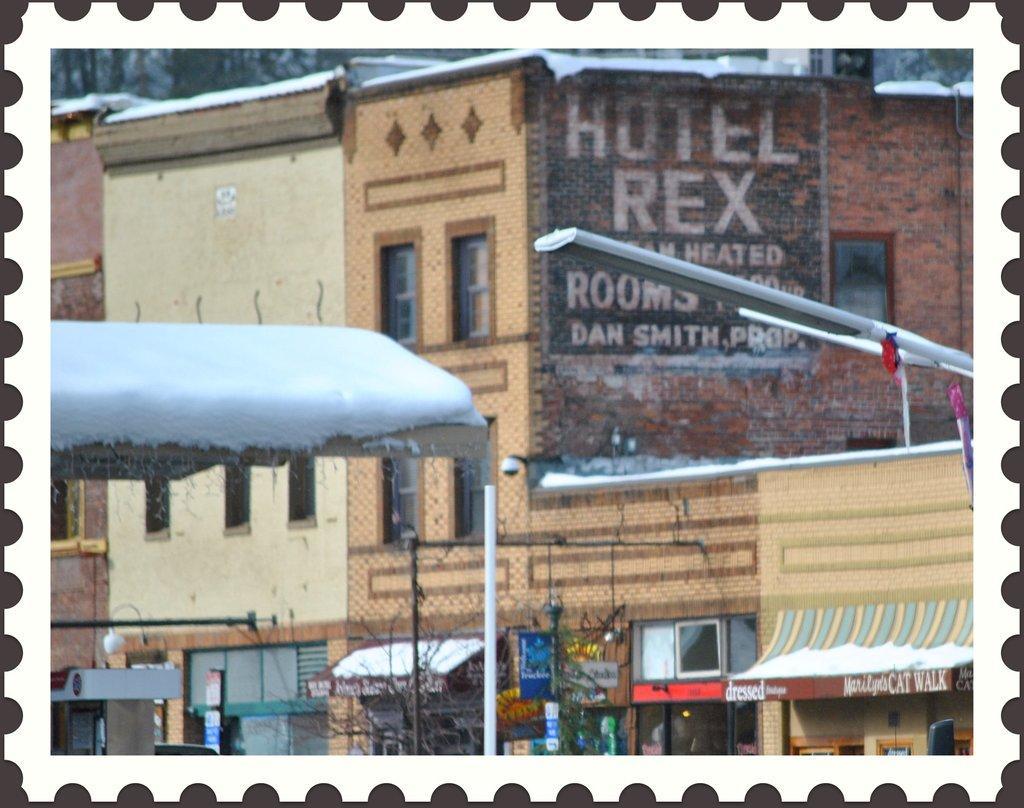Could you give a brief overview of what you see in this image? In this image there are buildings, in front of the buildings there are shops, in front of the shops there are lamp posts, CCTVs and trees. 